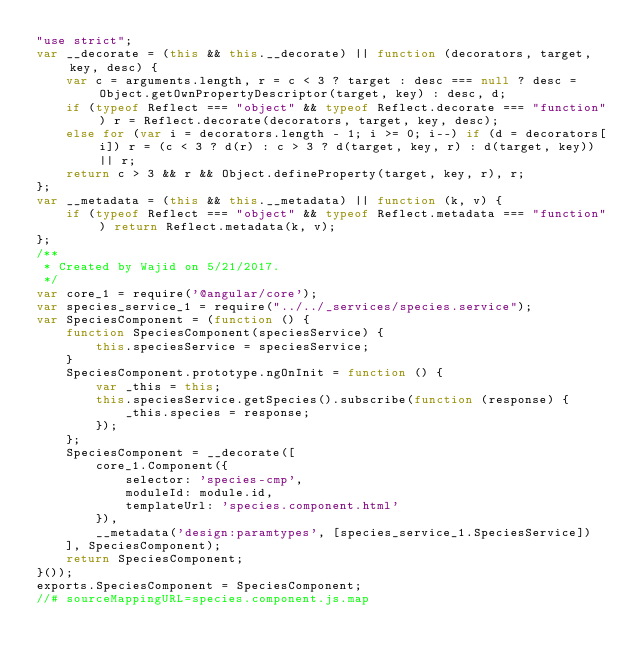<code> <loc_0><loc_0><loc_500><loc_500><_JavaScript_>"use strict";
var __decorate = (this && this.__decorate) || function (decorators, target, key, desc) {
    var c = arguments.length, r = c < 3 ? target : desc === null ? desc = Object.getOwnPropertyDescriptor(target, key) : desc, d;
    if (typeof Reflect === "object" && typeof Reflect.decorate === "function") r = Reflect.decorate(decorators, target, key, desc);
    else for (var i = decorators.length - 1; i >= 0; i--) if (d = decorators[i]) r = (c < 3 ? d(r) : c > 3 ? d(target, key, r) : d(target, key)) || r;
    return c > 3 && r && Object.defineProperty(target, key, r), r;
};
var __metadata = (this && this.__metadata) || function (k, v) {
    if (typeof Reflect === "object" && typeof Reflect.metadata === "function") return Reflect.metadata(k, v);
};
/**
 * Created by Wajid on 5/21/2017.
 */
var core_1 = require('@angular/core');
var species_service_1 = require("../../_services/species.service");
var SpeciesComponent = (function () {
    function SpeciesComponent(speciesService) {
        this.speciesService = speciesService;
    }
    SpeciesComponent.prototype.ngOnInit = function () {
        var _this = this;
        this.speciesService.getSpecies().subscribe(function (response) {
            _this.species = response;
        });
    };
    SpeciesComponent = __decorate([
        core_1.Component({
            selector: 'species-cmp',
            moduleId: module.id,
            templateUrl: 'species.component.html'
        }), 
        __metadata('design:paramtypes', [species_service_1.SpeciesService])
    ], SpeciesComponent);
    return SpeciesComponent;
}());
exports.SpeciesComponent = SpeciesComponent;
//# sourceMappingURL=species.component.js.map</code> 